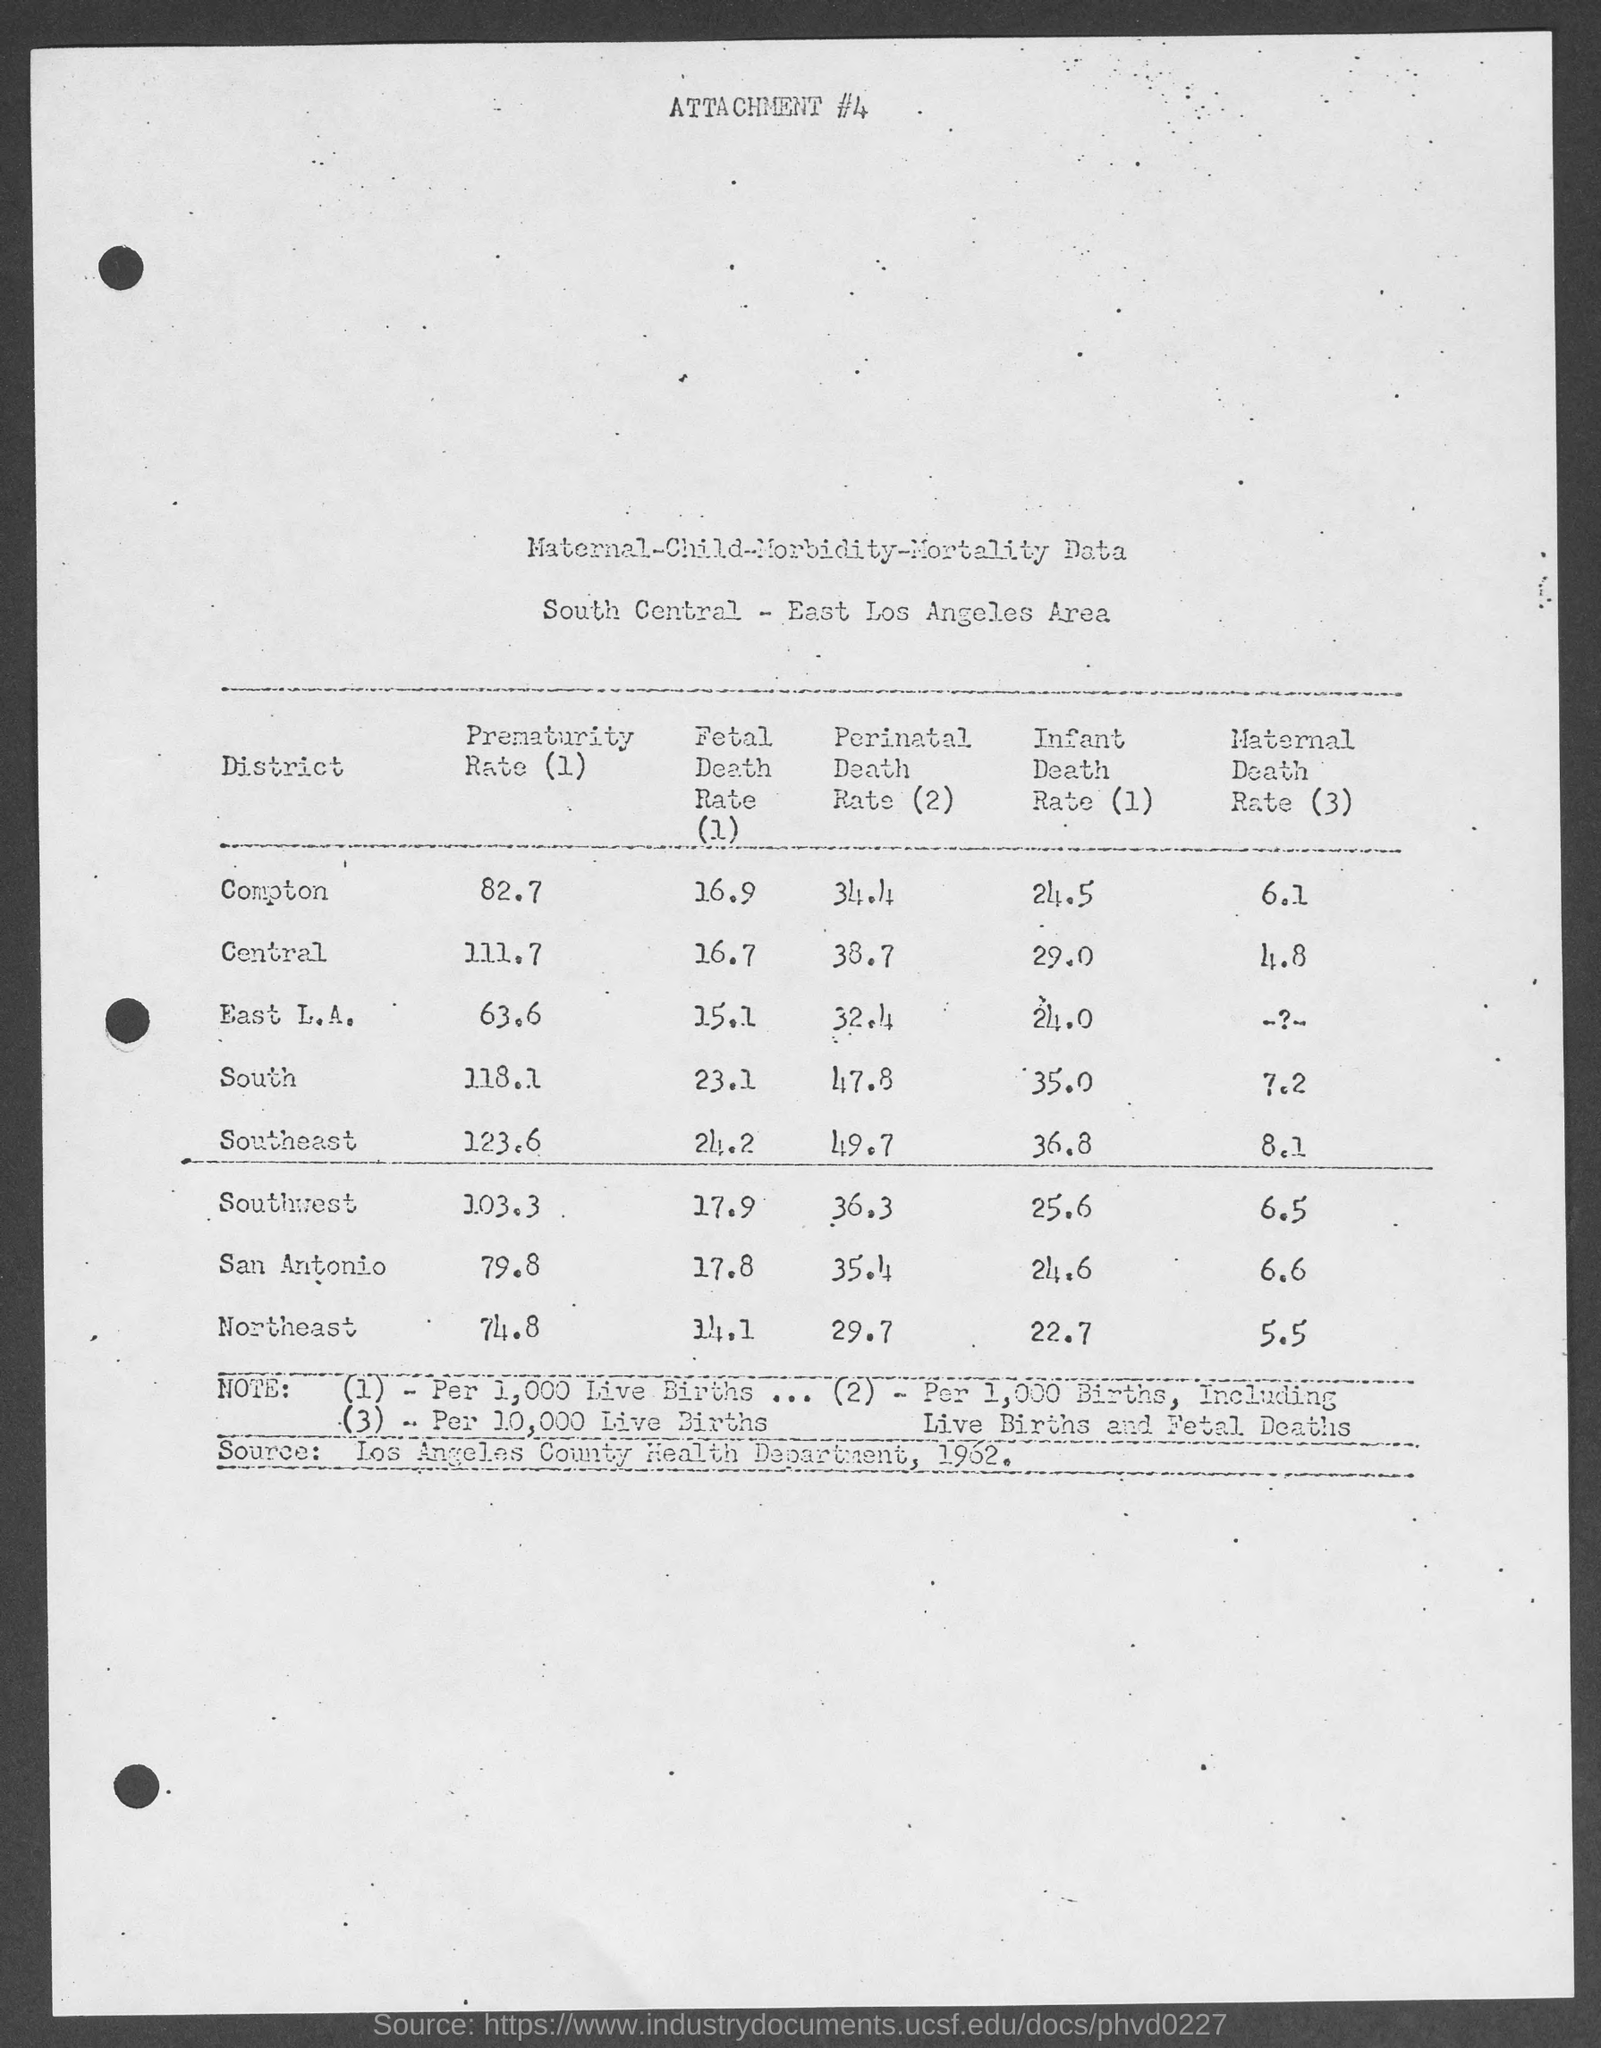What data this attachment #4 refers ?
Ensure brevity in your answer.  Maternal-Child-Morbidity-Mortality Data. What is the prematurity rate in east l.a. ?
Offer a terse response. 63.6. What is the infant death rate in south ?
Offer a terse response. 35.0. What is the maternal death rate in southeast ?
Ensure brevity in your answer.  8.1. 